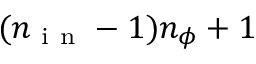<formula> <loc_0><loc_0><loc_500><loc_500>( n _ { i n } - 1 ) n _ { \phi } + 1</formula> 